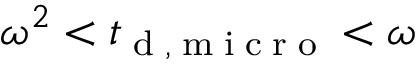<formula> <loc_0><loc_0><loc_500><loc_500>\omega ^ { 2 } < { t } _ { d , m i c r o } < \omega</formula> 